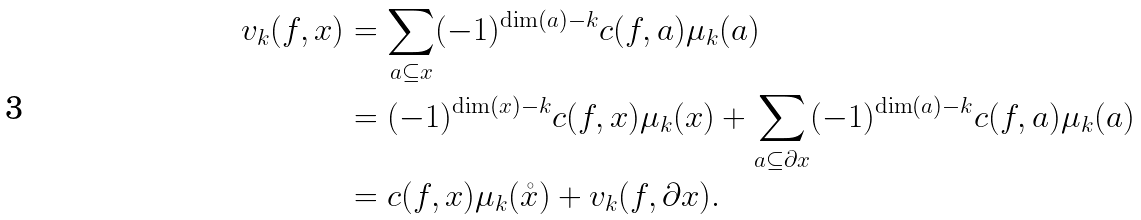<formula> <loc_0><loc_0><loc_500><loc_500>v _ { k } ( f , x ) & = \sum _ { a \subseteq x } ( - 1 ) ^ { \dim ( a ) - k } c ( f , a ) \mu _ { k } ( a ) \\ & = ( - 1 ) ^ { \dim ( x ) - k } c ( f , x ) \mu _ { k } ( x ) + \sum _ { a \subseteq \partial x } ( - 1 ) ^ { \dim ( a ) - k } c ( f , a ) \mu _ { k } ( a ) \\ & = c ( f , x ) \mu _ { k } ( \mathring { x } ) + v _ { k } ( f , \partial x ) .</formula> 